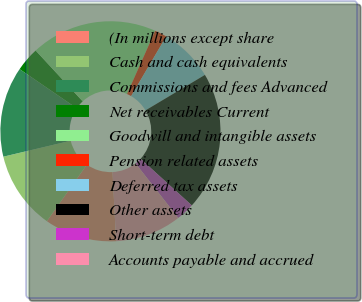Convert chart. <chart><loc_0><loc_0><loc_500><loc_500><pie_chart><fcel>(In millions except share<fcel>Cash and cash equivalents<fcel>Commissions and fees Advanced<fcel>Net receivables Current<fcel>Goodwill and intangible assets<fcel>Pension related assets<fcel>Deferred tax assets<fcel>Other assets<fcel>Short-term debt<fcel>Accounts payable and accrued<nl><fcel>10.62%<fcel>11.5%<fcel>13.26%<fcel>3.56%<fcel>18.55%<fcel>1.8%<fcel>7.97%<fcel>20.32%<fcel>2.68%<fcel>9.74%<nl></chart> 